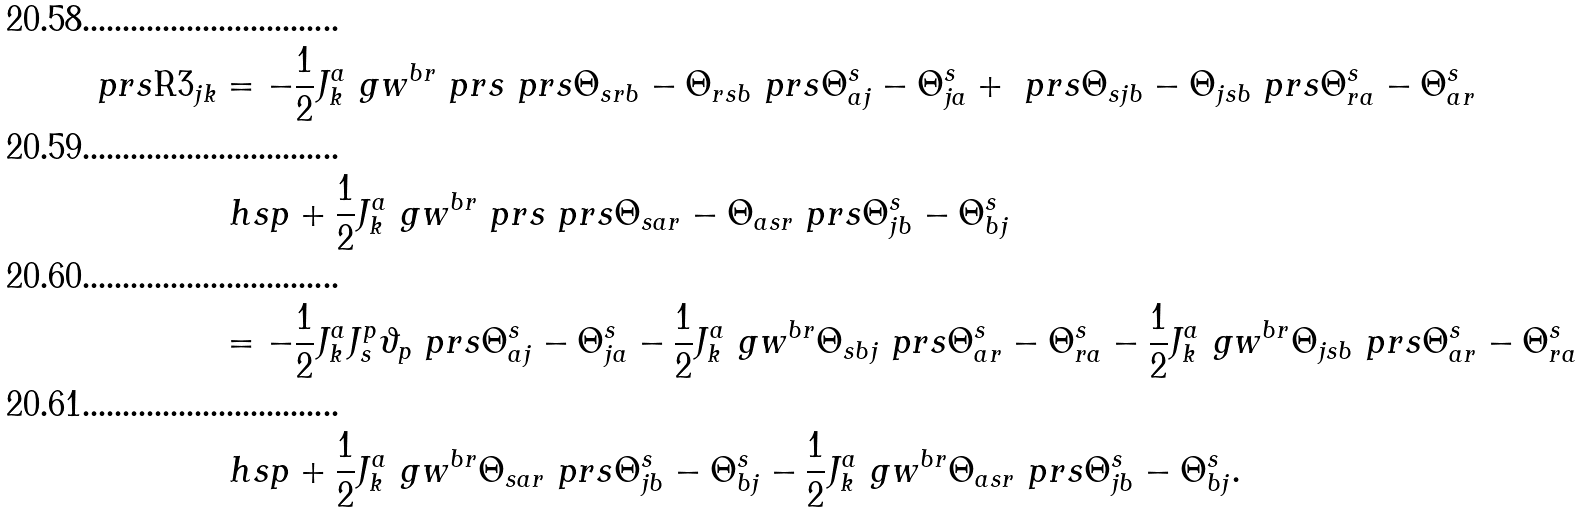Convert formula to latex. <formula><loc_0><loc_0><loc_500><loc_500>\ p r s { \text {R3} } _ { j k } & = - \frac { 1 } { 2 } J _ { k } ^ { a } \ g w ^ { b r } \ p r s { \ p r s { \Theta _ { s r b } - \Theta _ { r s b } } \ p r s { \Theta _ { a j } ^ { s } - \Theta _ { j a } ^ { s } } + \ p r s { \Theta _ { s j b } - \Theta _ { j s b } } \ p r s { \Theta _ { r a } ^ { s } - \Theta _ { a r } ^ { s } } } \\ & \ h s p + \frac { 1 } { 2 } J _ { k } ^ { a } \ g w ^ { b r } \ p r s { \ p r s { \Theta _ { s a r } - \Theta _ { a s r } } \ p r s { \Theta _ { j b } ^ { s } - \Theta _ { b j } ^ { s } } } \\ & = - \frac { 1 } { 2 } J _ { k } ^ { a } J _ { s } ^ { p } \vartheta _ { p } \ p r s { \Theta _ { a j } ^ { s } - \Theta _ { j a } ^ { s } } - \frac { 1 } { 2 } J _ { k } ^ { a } \ g w ^ { b r } \Theta _ { s b j } \ p r s { \Theta _ { a r } ^ { s } - \Theta _ { r a } ^ { s } } - \frac { 1 } { 2 } J _ { k } ^ { a } \ g w ^ { b r } \Theta _ { j s b } \ p r s { \Theta _ { a r } ^ { s } - \Theta _ { r a } ^ { s } } \\ & \ h s p + \frac { 1 } { 2 } J _ { k } ^ { a } \ g w ^ { b r } \Theta _ { s a r } \ p r s { \Theta _ { j b } ^ { s } - \Theta _ { b j } ^ { s } } - \frac { 1 } { 2 } J _ { k } ^ { a } \ g w ^ { b r } \Theta _ { a s r } \ p r s { \Theta _ { j b } ^ { s } - \Theta _ { b j } ^ { s } } .</formula> 